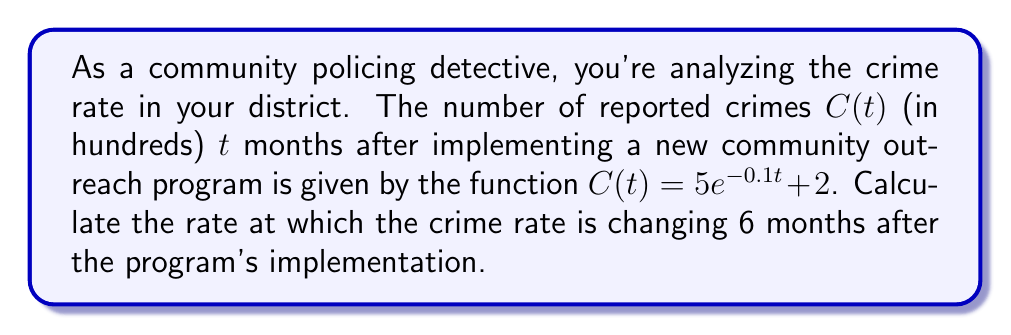Give your solution to this math problem. To find the rate at which the crime rate is changing, we need to calculate the derivative of the function $C(t)$ and evaluate it at $t = 6$. Let's break this down step-by-step:

1) The given function is $C(t) = 5e^{-0.1t} + 2$

2) To find the derivative, we use the chain rule on the exponential term and the constant rule on the +2:

   $\frac{dC}{dt} = 5 \cdot (-0.1) \cdot e^{-0.1t} + 0$

3) Simplify:

   $\frac{dC}{dt} = -0.5e^{-0.1t}$

4) Now, we need to evaluate this at $t = 6$:

   $\frac{dC}{dt}\bigg|_{t=6} = -0.5e^{-0.1(6)}$

5) Calculate:

   $\frac{dC}{dt}\bigg|_{t=6} = -0.5e^{-0.6} \approx -0.2746$

6) Interpret the result: The negative value indicates that the crime rate is decreasing. The rate of change is approximately -0.2746 hundred crimes per month, or about -27.46 crimes per month.
Answer: $-0.2746$ hundred crimes per month 